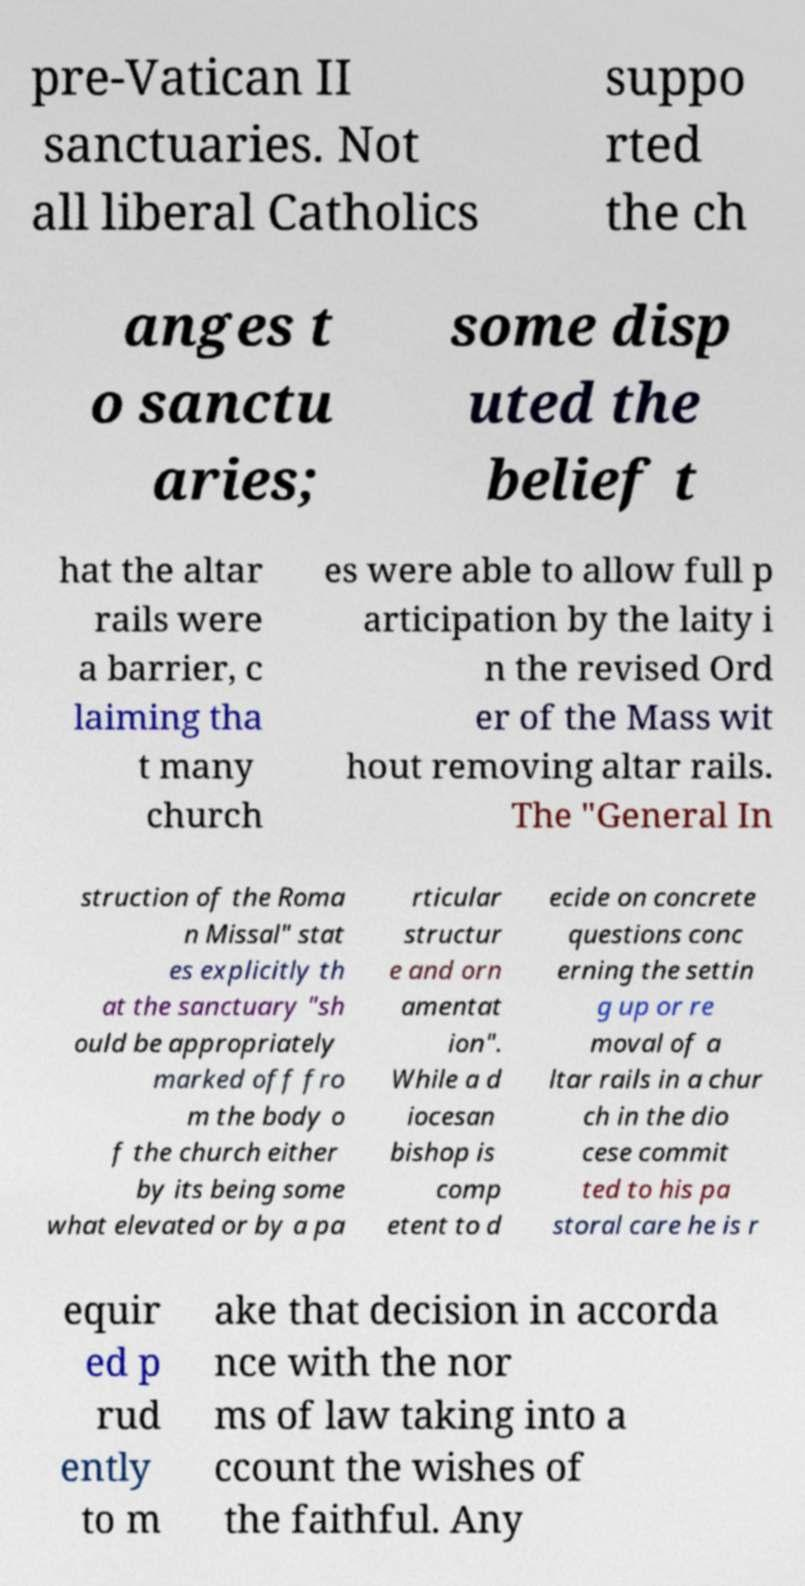Could you assist in decoding the text presented in this image and type it out clearly? pre-Vatican II sanctuaries. Not all liberal Catholics suppo rted the ch anges t o sanctu aries; some disp uted the belief t hat the altar rails were a barrier, c laiming tha t many church es were able to allow full p articipation by the laity i n the revised Ord er of the Mass wit hout removing altar rails. The "General In struction of the Roma n Missal" stat es explicitly th at the sanctuary "sh ould be appropriately marked off fro m the body o f the church either by its being some what elevated or by a pa rticular structur e and orn amentat ion". While a d iocesan bishop is comp etent to d ecide on concrete questions conc erning the settin g up or re moval of a ltar rails in a chur ch in the dio cese commit ted to his pa storal care he is r equir ed p rud ently to m ake that decision in accorda nce with the nor ms of law taking into a ccount the wishes of the faithful. Any 